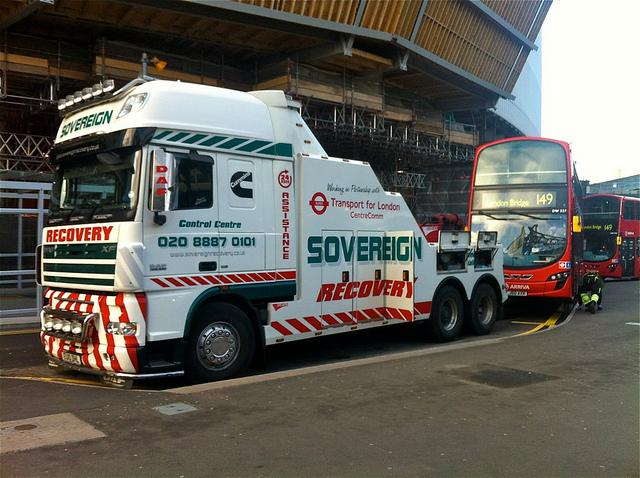Where is Sovereign Recovery located? Please explain your reasoning. st albans. The text on the truck says st. albans. 